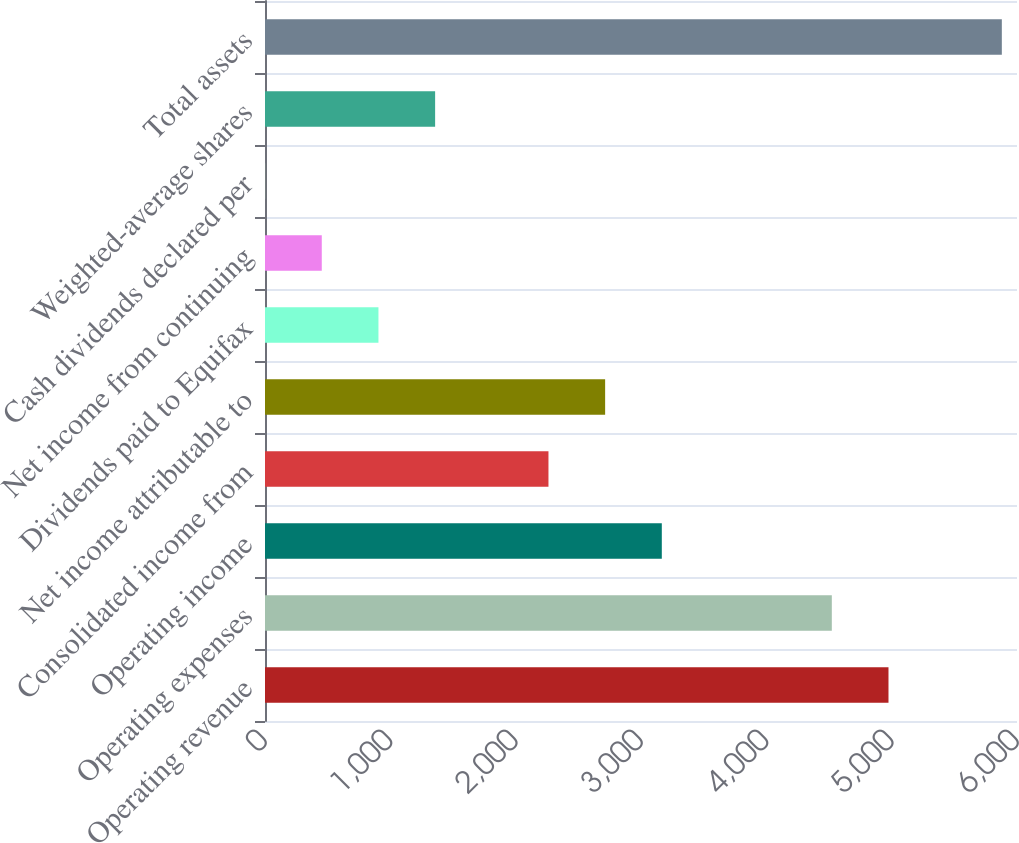Convert chart to OTSL. <chart><loc_0><loc_0><loc_500><loc_500><bar_chart><fcel>Operating revenue<fcel>Operating expenses<fcel>Operating income<fcel>Consolidated income from<fcel>Net income attributable to<fcel>Dividends paid to Equifax<fcel>Net income from continuing<fcel>Cash dividends declared per<fcel>Weighted-average shares<fcel>Total assets<nl><fcel>4974.64<fcel>4522.48<fcel>3166<fcel>2261.68<fcel>2713.84<fcel>905.2<fcel>453.04<fcel>0.88<fcel>1357.36<fcel>5878.96<nl></chart> 